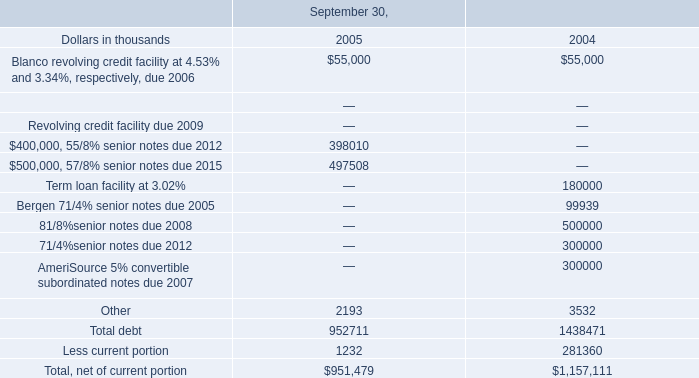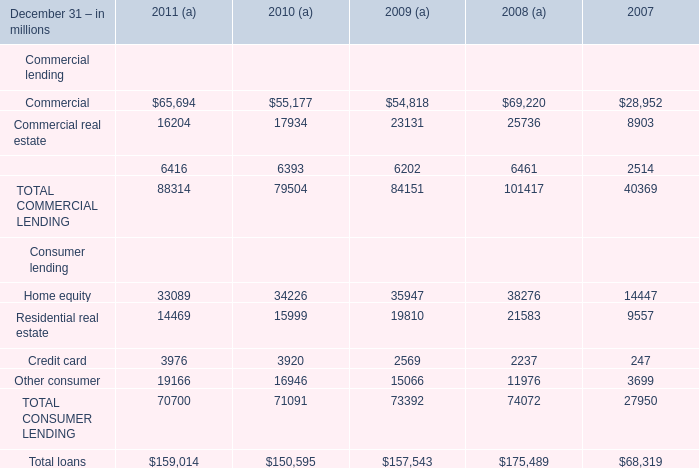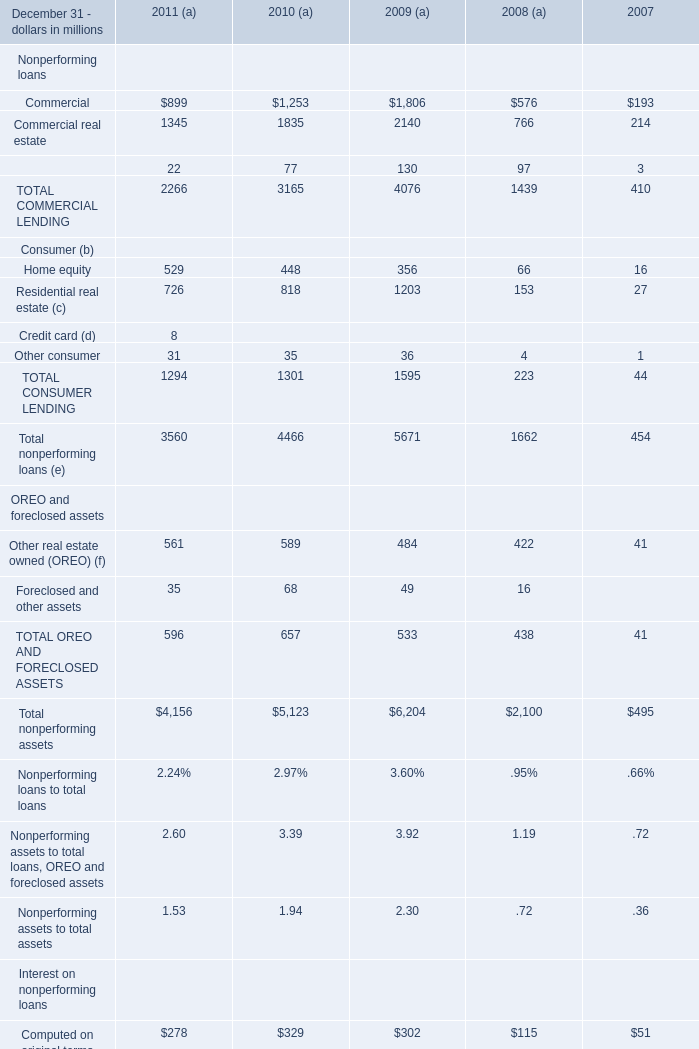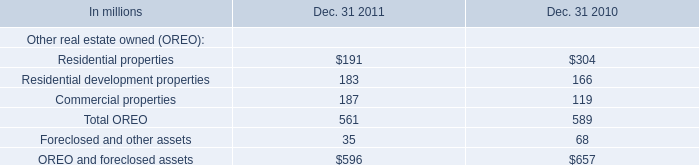What is the proportion of Commercial to the Total loans in 2011? 
Computations: (65694 / 159014)
Answer: 0.41313. 